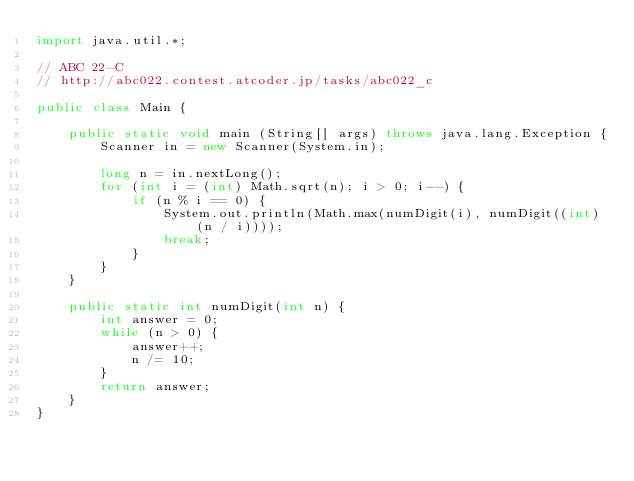Convert code to text. <code><loc_0><loc_0><loc_500><loc_500><_Java_>import java.util.*;

// ABC 22-C
// http://abc022.contest.atcoder.jp/tasks/abc022_c
 
public class Main {

	public static void main (String[] args) throws java.lang.Exception {
		Scanner in = new Scanner(System.in);
		
		long n = in.nextLong();
		for (int i = (int) Math.sqrt(n); i > 0; i--) {
			if (n % i == 0) {
				System.out.println(Math.max(numDigit(i), numDigit((int) (n / i))));
				break;
			}
		}
	}
	
	public static int numDigit(int n) {
		int answer = 0;
		while (n > 0) {
			answer++;
			n /= 10;
		}
		return answer;
	}
}</code> 